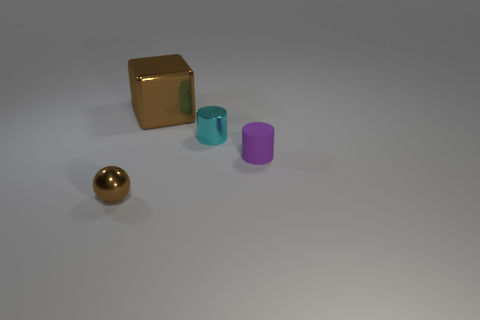Add 1 blue metal blocks. How many objects exist? 5 Subtract all spheres. How many objects are left? 3 Subtract all cyan cylinders. How many cylinders are left? 1 Subtract 1 cyan cylinders. How many objects are left? 3 Subtract 1 blocks. How many blocks are left? 0 Subtract all blue cylinders. Subtract all green blocks. How many cylinders are left? 2 Subtract all red blocks. How many green cylinders are left? 0 Subtract all rubber things. Subtract all red cylinders. How many objects are left? 3 Add 2 big brown metallic blocks. How many big brown metallic blocks are left? 3 Add 2 big gray balls. How many big gray balls exist? 2 